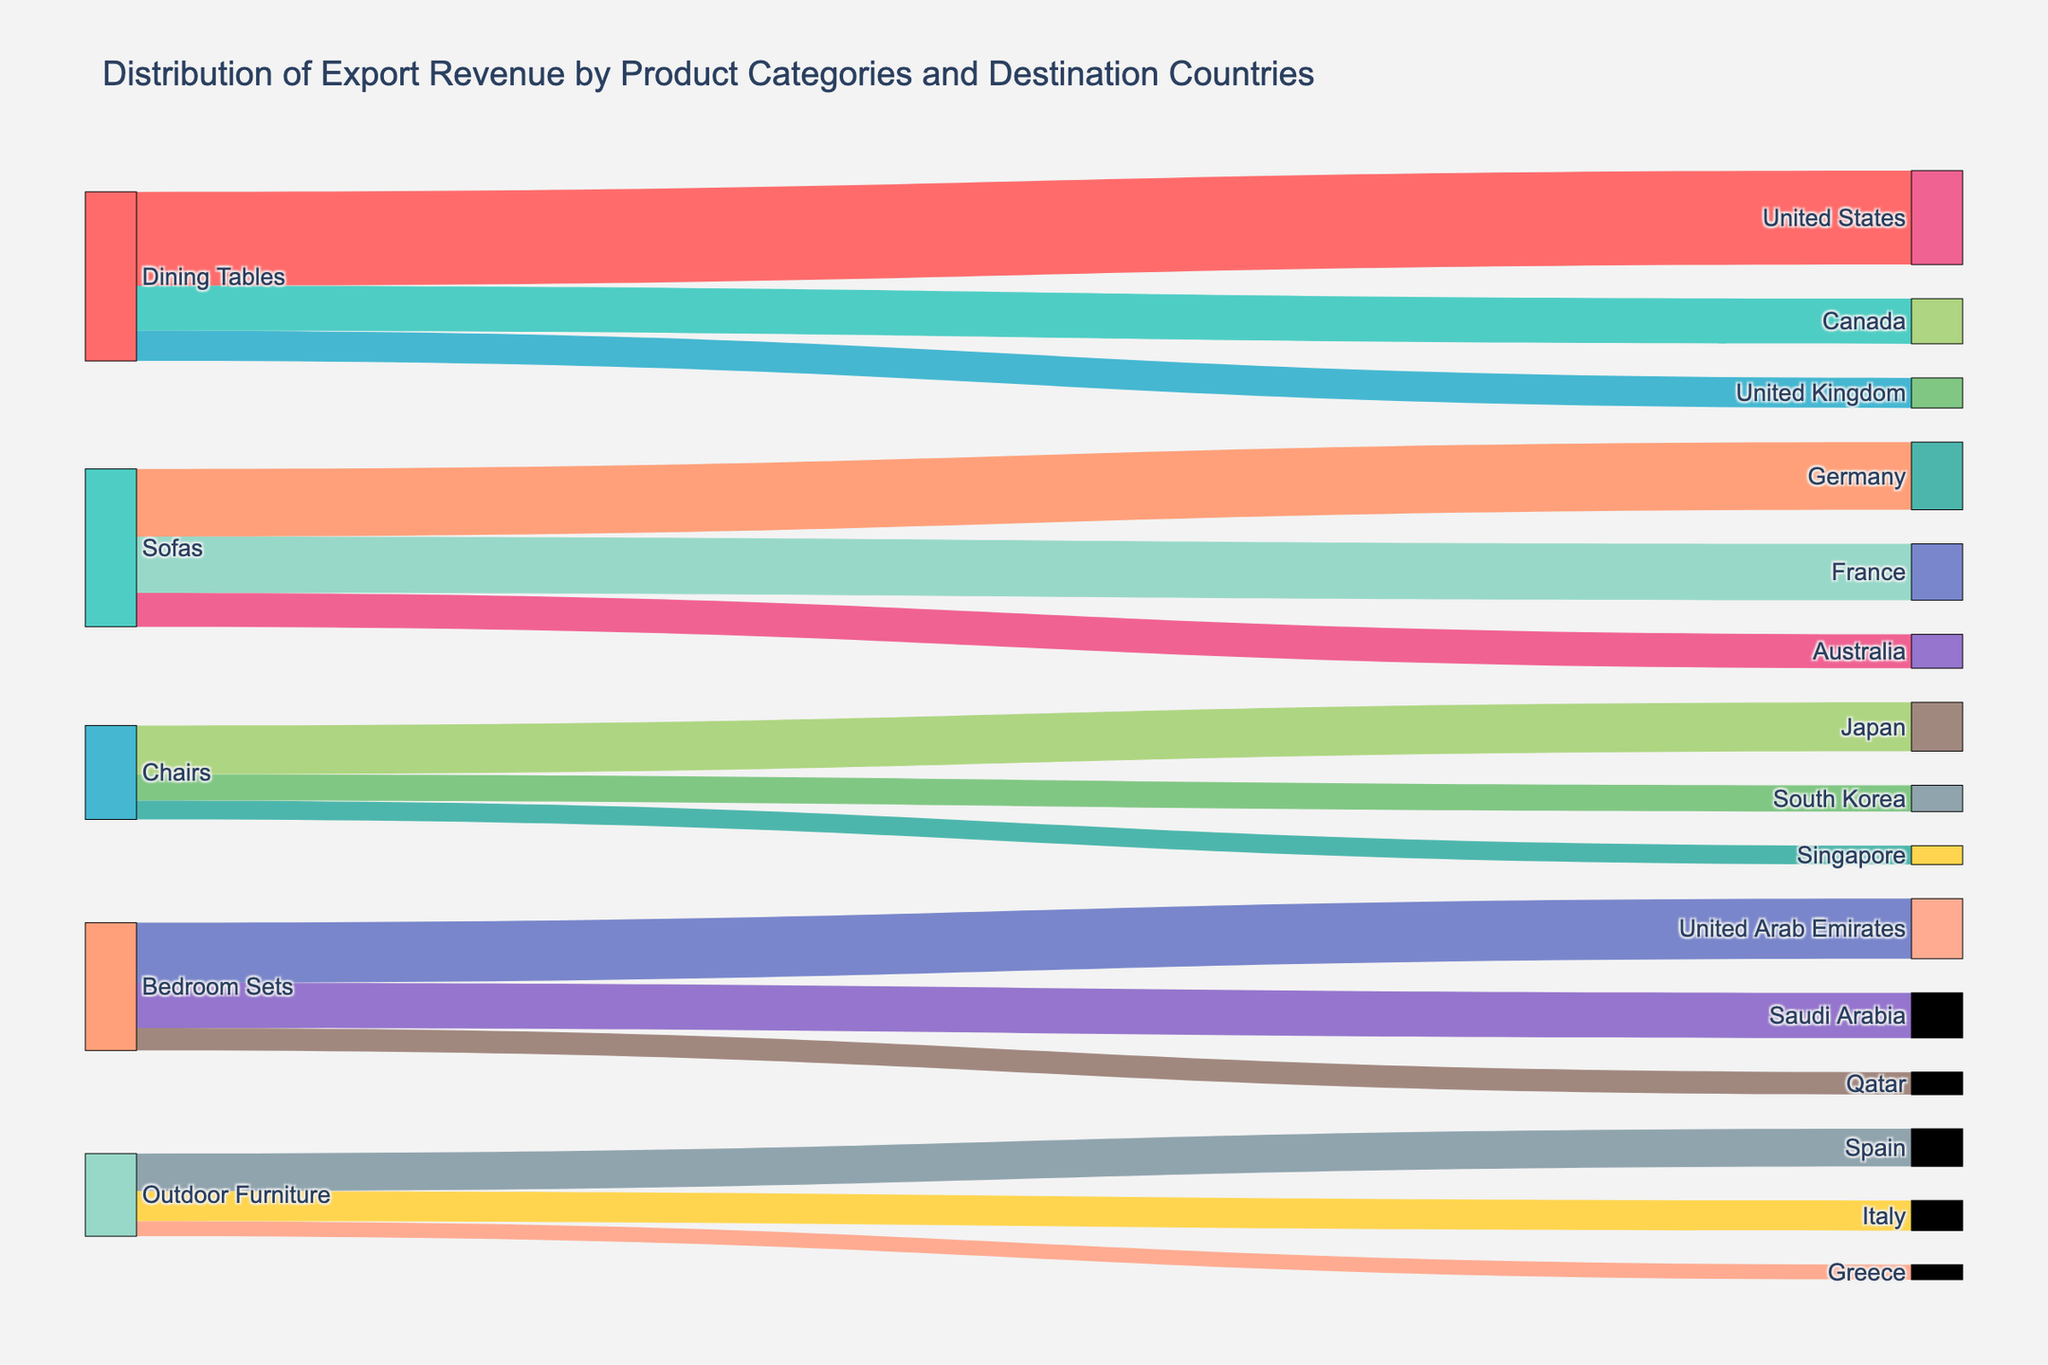What's the title of the figure? The title is typically found at the top of the figure. In this case, it is specified in the code and reads "Distribution of Export Revenue by Product Categories and Destination Countries".
Answer: Distribution of Export Revenue by Product Categories and Destination Countries Which product category has the highest export revenue to the United States? Identify the flows connecting each product category to the United States. The width of the link indicates the value. Dining Tables has the widest link to the United States with a value of 2,500,000.
Answer: Dining Tables How many destination countries are there in total? Count the unique destination countries mentioned in the target column. There are 12 destination countries listed: United States, Canada, United Kingdom, Germany, France, Australia, Japan, South Korea, Singapore, United Arab Emirates, Saudi Arabia, Qatar, Spain, Italy, and Greece.
Answer: 12 What is the total export revenue for Sofas? Sum the values of all flows originating from Sofas: Germany (1,800,000), France (1,500,000), and Australia (900,000). The total is 1,800,000 + 1,500,000 + 900,000 = 4,200,000.
Answer: 4,200,000 Which product category contributes to the highest total export revenue? Calculate the total export revenue for each product category and compare. Dining Tables: 2,500,000 + 1,200,000 + 800,000 = 4,500,000; Sofas: 4,200,000; Chairs: 1,300,000 + 700,000 + 500,000 = 2,500,000; Bedroom Sets: 1,600,000 + 1,200,000 + 600,000 = 3,400,000; Outdoor Furniture: 1,000,000 + 800,000 + 400,000 = 2,200,000. Dining Tables has the highest total export revenue.
Answer: Dining Tables Which two destination countries receive the largest export revenue from Bedroom Sets? Observe the values of flows from Bedroom Sets. The highest values are for United Arab Emirates (1,600,000) and Saudi Arabia (1,200,000), which are the top two.
Answer: United Arab Emirates and Saudi Arabia How much more export revenue do Dining Tables generate in the United States compared to the United Kingdom? Compare the values for Dining Tables to the United States (2,500,000) and the United Kingdom (800,000). The difference is 2,500,000 - 800,000 = 1,700,000.
Answer: 1,700,000 What percentage of the total export revenue for Chairs is to Japan? Calculate the total export revenue for Chairs: 1,300,000 + 700,000 + 500,000 = 2,500,000. The export revenue to Japan is 1,300,000. The percentage is (1,300,000 / 2,500,000) * 100 = 52%.
Answer: 52% Which destination country receives the least export revenue from Outdoor Furniture? Observe the values of flows from Outdoor Furniture. The smallest value is for Greece (400,000).
Answer: Greece What is the combined export revenue for the Middle Eastern countries (United Arab Emirates, Saudi Arabia, and Qatar) for Bedroom Sets? Sum the values for Bedroom Sets to United Arab Emirates (1,600,000), Saudi Arabia (1,200,000), and Qatar (600,000). The total is 1,600,000 + 1,200,000 + 600,000 = 3,400,000.
Answer: 3,400,000 